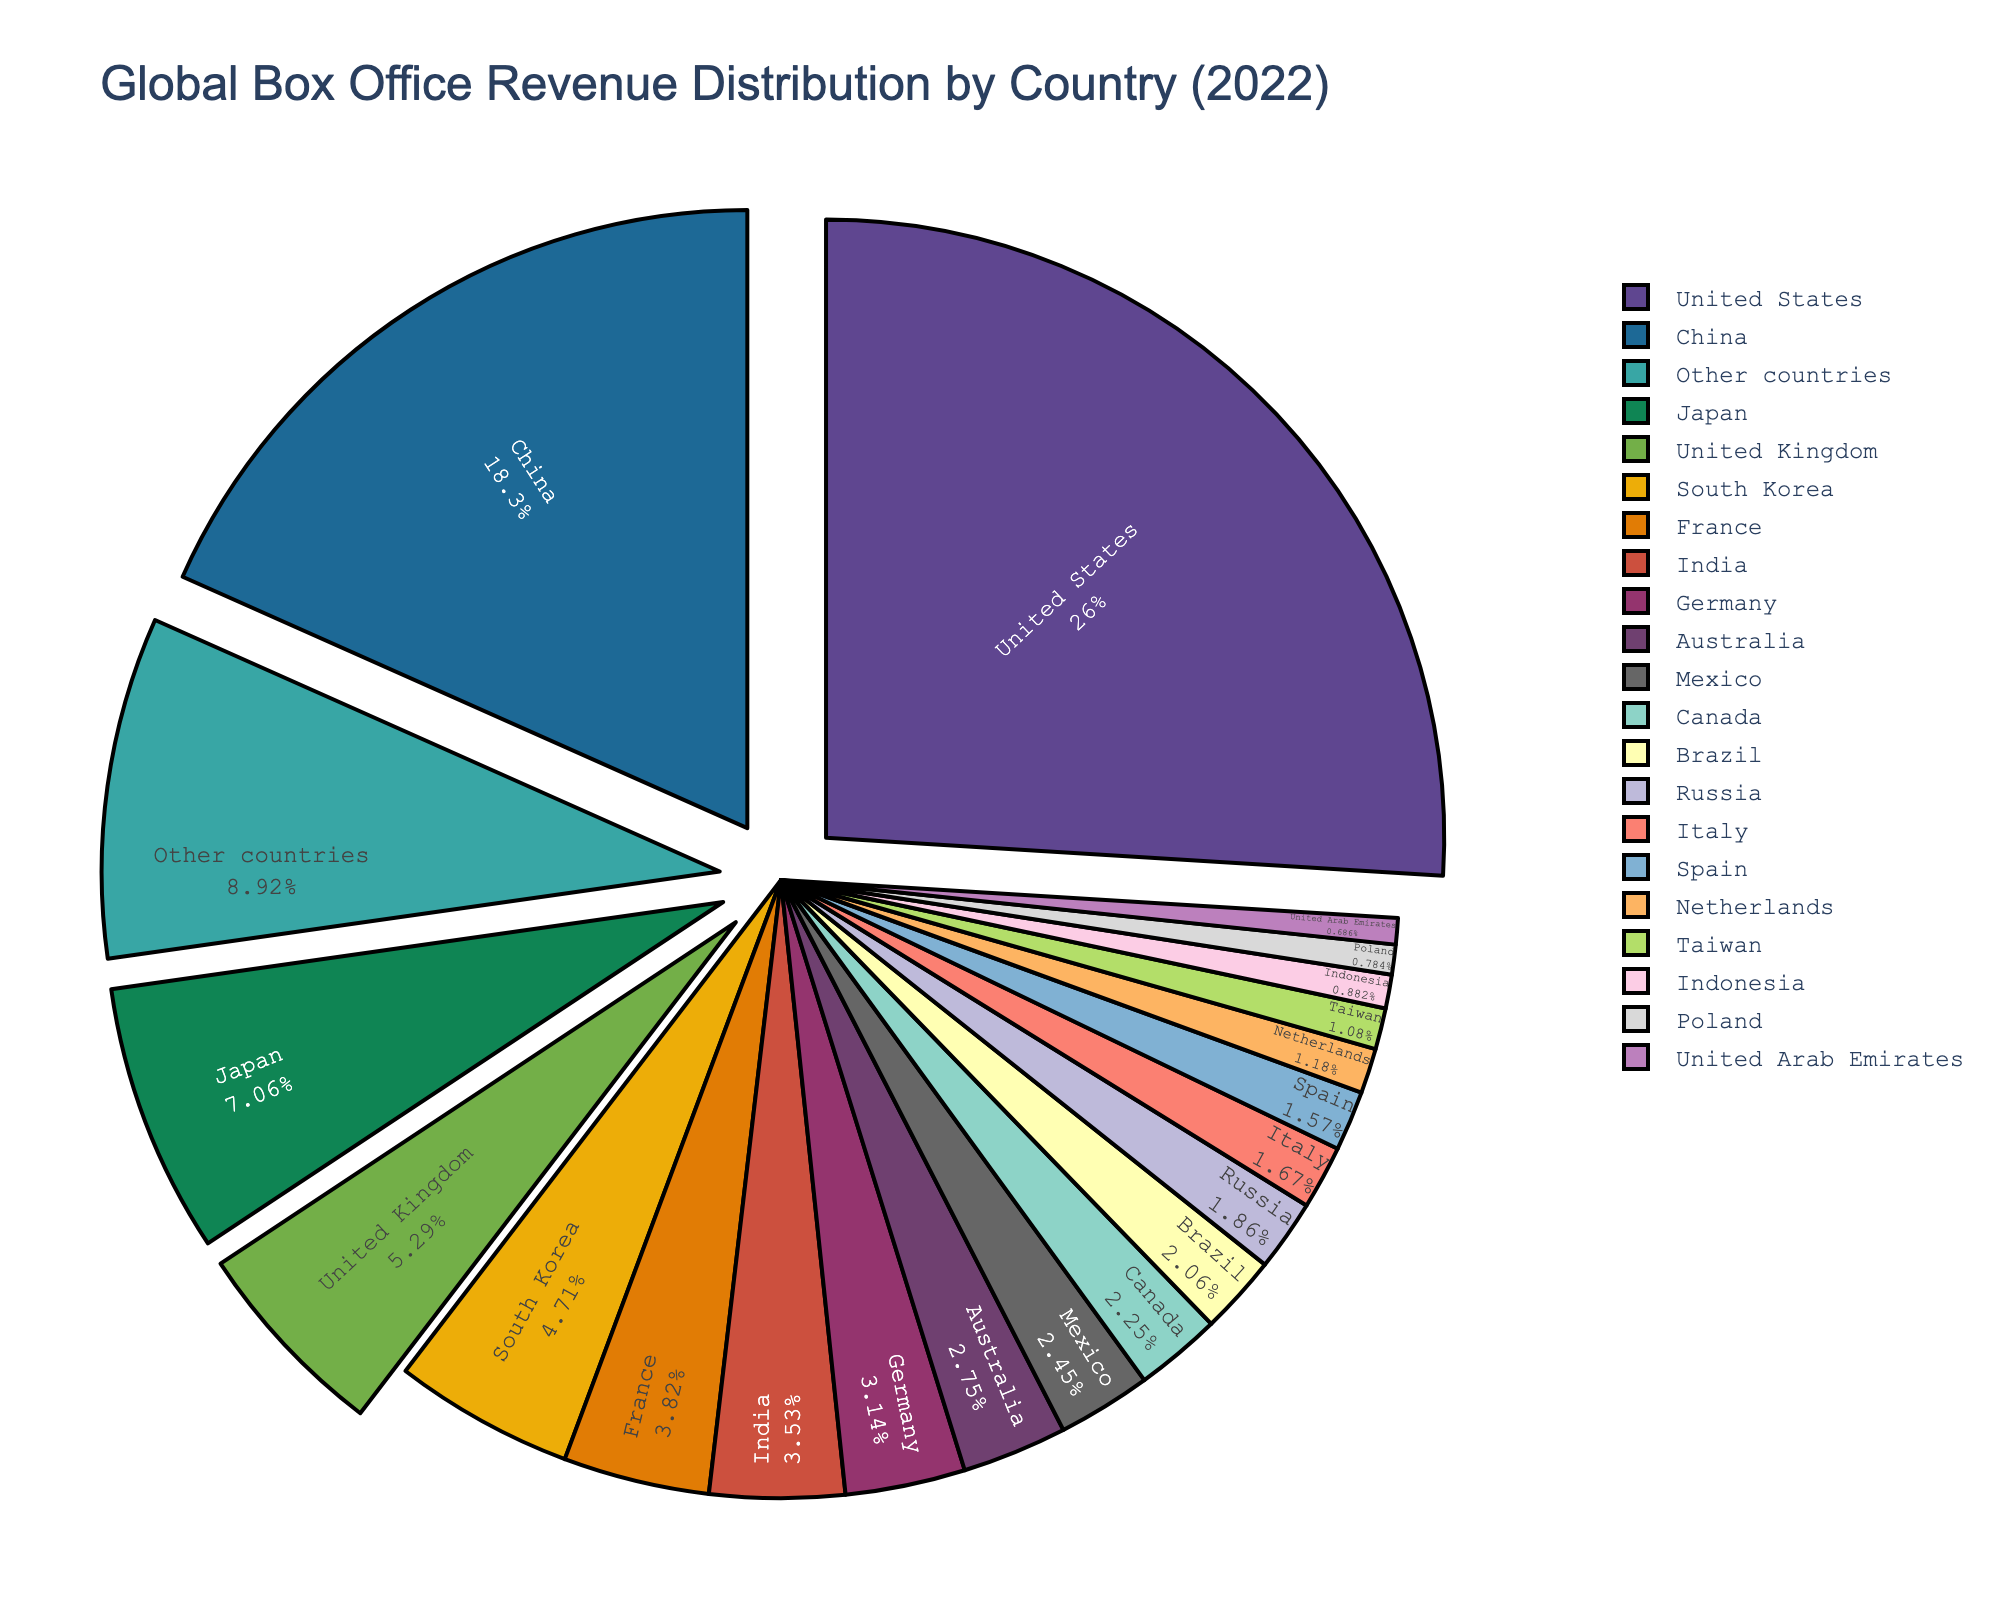Which country had the highest global box office revenue share in 2022? The United States had the highest percentage of global box office revenue, as indicated by the largest segment in the pie chart.
Answer: United States How much larger is the percentage of box office revenue in the United States compared to China? The United States had 26.5% and China had 18.7%. The difference is 26.5 - 18.7 = 7.8%.
Answer: 7.8% Which countries have box office revenue shares between 2% and 4%? According to the pie chart, the countries with percentages in this range are France (3.9%), India (3.6%), Germany (3.2%), Australia (2.8%), Mexico (2.5%), and Canada (2.3%).
Answer: France, India, Germany, Australia, Mexico, Canada What is the combined percentage of box office revenue from Japan and South Korea? Japan has 7.2% and South Korea has 4.8%. The combined percentage is 7.2 + 4.8 = 12%.
Answer: 12% Which country has a box office revenue share closest to that of Italy? Spain has a box office revenue share of 1.6%, which is closest to Italy's 1.7%.
Answer: Spain What is the total percentage of box office revenue for the highest three countries? The percentages for the United States, China, and Japan are 26.5%, 18.7%, and 7.2%, respectively. The total is 26.5 + 18.7 + 7.2 = 52.4%.
Answer: 52.4% How does France's box office revenue share compare to that of the United Kingdom? The United Kingdom has a 5.4% share, while France has 3.9%. The United Kingdom's share is higher by 5.4 - 3.9 = 1.5%.
Answer: United Kingdom by 1.5% What is the average percentage share of global box office revenue for the bottom five countries? The percentages for Indonesia, Poland, United Arab Emirates, and other countries are 0.9%, 0.8%, 0.7%, and 9.1%. The average is (0.9 + 0.8 + 0.7 + 9.1) / 5 = 2.3%.
Answer: 2.3% Which segment is represented by a color towards the end of the custom palette, such as a light color? The segment for "Other countries" has a 9.1% share and is colored towards the end of the palette with a lighter color.
Answer: Other countries 